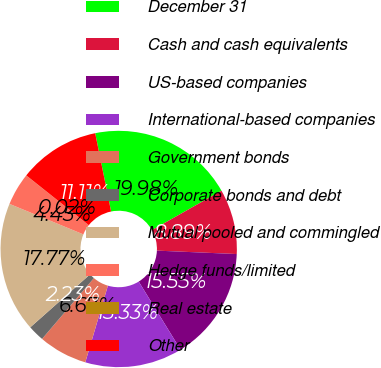<chart> <loc_0><loc_0><loc_500><loc_500><pie_chart><fcel>December 31<fcel>Cash and cash equivalents<fcel>US-based companies<fcel>International-based companies<fcel>Government bonds<fcel>Corporate bonds and debt<fcel>Mutual pooled and commingled<fcel>Hedge funds/limited<fcel>Real estate<fcel>Other<nl><fcel>19.98%<fcel>8.89%<fcel>15.55%<fcel>13.33%<fcel>6.67%<fcel>2.23%<fcel>17.77%<fcel>4.45%<fcel>0.02%<fcel>11.11%<nl></chart> 